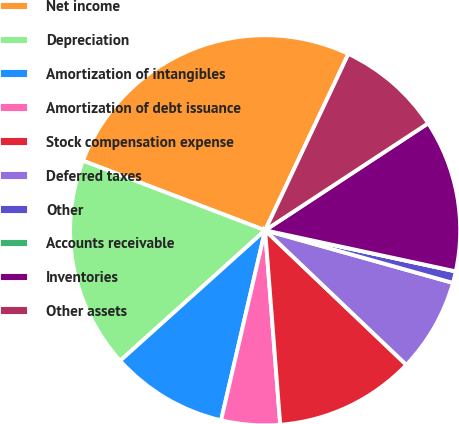Convert chart to OTSL. <chart><loc_0><loc_0><loc_500><loc_500><pie_chart><fcel>Net income<fcel>Depreciation<fcel>Amortization of intangibles<fcel>Amortization of debt issuance<fcel>Stock compensation expense<fcel>Deferred taxes<fcel>Other<fcel>Accounts receivable<fcel>Inventories<fcel>Other assets<nl><fcel>26.21%<fcel>17.47%<fcel>9.71%<fcel>4.86%<fcel>11.65%<fcel>7.77%<fcel>0.97%<fcel>0.0%<fcel>12.62%<fcel>8.74%<nl></chart> 